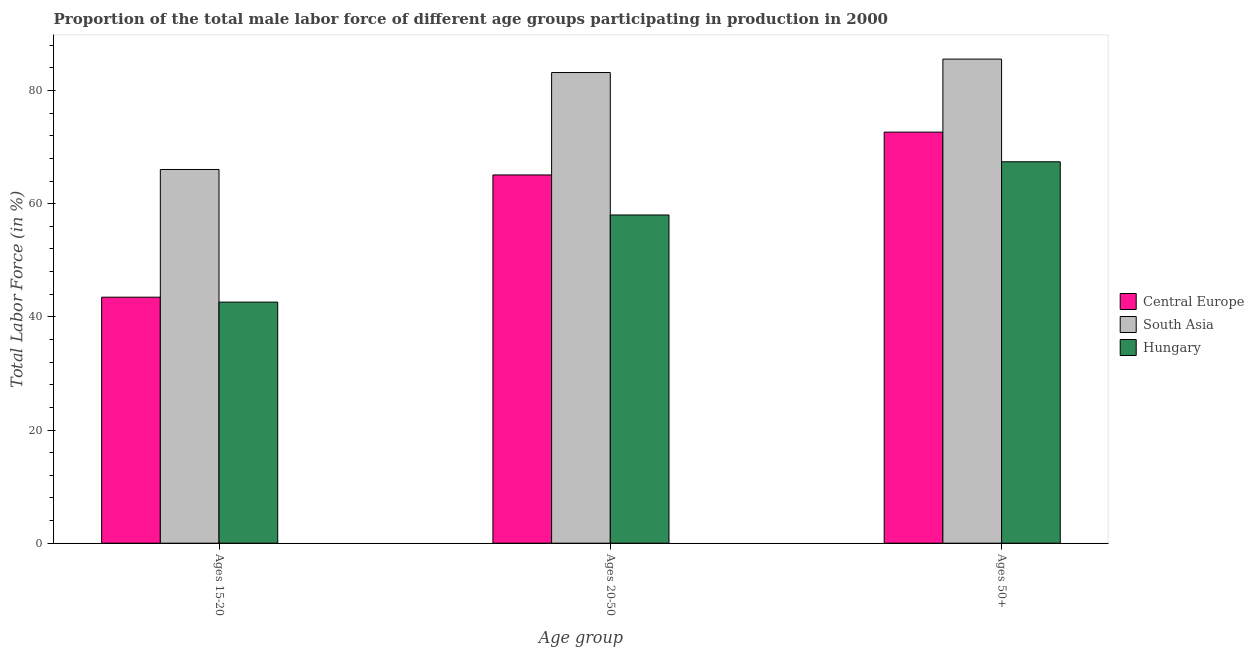How many different coloured bars are there?
Your answer should be compact. 3. How many groups of bars are there?
Provide a succinct answer. 3. Are the number of bars per tick equal to the number of legend labels?
Offer a very short reply. Yes. Are the number of bars on each tick of the X-axis equal?
Offer a very short reply. Yes. How many bars are there on the 1st tick from the left?
Provide a short and direct response. 3. How many bars are there on the 1st tick from the right?
Your answer should be very brief. 3. What is the label of the 1st group of bars from the left?
Offer a terse response. Ages 15-20. What is the percentage of male labor force above age 50 in Central Europe?
Ensure brevity in your answer.  72.64. Across all countries, what is the maximum percentage of male labor force within the age group 15-20?
Provide a short and direct response. 66.04. Across all countries, what is the minimum percentage of male labor force within the age group 20-50?
Your answer should be compact. 58. In which country was the percentage of male labor force within the age group 20-50 maximum?
Provide a succinct answer. South Asia. In which country was the percentage of male labor force above age 50 minimum?
Provide a short and direct response. Hungary. What is the total percentage of male labor force above age 50 in the graph?
Keep it short and to the point. 225.59. What is the difference between the percentage of male labor force above age 50 in Central Europe and that in Hungary?
Your response must be concise. 5.24. What is the difference between the percentage of male labor force within the age group 20-50 in South Asia and the percentage of male labor force above age 50 in Hungary?
Make the answer very short. 15.77. What is the average percentage of male labor force within the age group 15-20 per country?
Your response must be concise. 50.7. What is the difference between the percentage of male labor force within the age group 20-50 and percentage of male labor force above age 50 in Hungary?
Ensure brevity in your answer.  -9.4. What is the ratio of the percentage of male labor force within the age group 15-20 in Central Europe to that in South Asia?
Your answer should be very brief. 0.66. Is the percentage of male labor force within the age group 20-50 in Hungary less than that in South Asia?
Your answer should be compact. Yes. What is the difference between the highest and the second highest percentage of male labor force within the age group 20-50?
Your answer should be very brief. 18.1. What is the difference between the highest and the lowest percentage of male labor force within the age group 20-50?
Provide a succinct answer. 25.17. In how many countries, is the percentage of male labor force within the age group 15-20 greater than the average percentage of male labor force within the age group 15-20 taken over all countries?
Your answer should be compact. 1. What does the 1st bar from the left in Ages 20-50 represents?
Ensure brevity in your answer.  Central Europe. What does the 3rd bar from the right in Ages 20-50 represents?
Your response must be concise. Central Europe. Is it the case that in every country, the sum of the percentage of male labor force within the age group 15-20 and percentage of male labor force within the age group 20-50 is greater than the percentage of male labor force above age 50?
Give a very brief answer. Yes. How many bars are there?
Provide a short and direct response. 9. Does the graph contain any zero values?
Give a very brief answer. No. Does the graph contain grids?
Provide a short and direct response. No. Where does the legend appear in the graph?
Give a very brief answer. Center right. How many legend labels are there?
Make the answer very short. 3. How are the legend labels stacked?
Keep it short and to the point. Vertical. What is the title of the graph?
Your answer should be compact. Proportion of the total male labor force of different age groups participating in production in 2000. Does "Suriname" appear as one of the legend labels in the graph?
Offer a terse response. No. What is the label or title of the X-axis?
Make the answer very short. Age group. What is the Total Labor Force (in %) in Central Europe in Ages 15-20?
Your answer should be compact. 43.47. What is the Total Labor Force (in %) of South Asia in Ages 15-20?
Your answer should be very brief. 66.04. What is the Total Labor Force (in %) in Hungary in Ages 15-20?
Offer a very short reply. 42.6. What is the Total Labor Force (in %) of Central Europe in Ages 20-50?
Give a very brief answer. 65.07. What is the Total Labor Force (in %) of South Asia in Ages 20-50?
Your response must be concise. 83.17. What is the Total Labor Force (in %) of Hungary in Ages 20-50?
Give a very brief answer. 58. What is the Total Labor Force (in %) in Central Europe in Ages 50+?
Make the answer very short. 72.64. What is the Total Labor Force (in %) of South Asia in Ages 50+?
Offer a terse response. 85.55. What is the Total Labor Force (in %) in Hungary in Ages 50+?
Keep it short and to the point. 67.4. Across all Age group, what is the maximum Total Labor Force (in %) of Central Europe?
Give a very brief answer. 72.64. Across all Age group, what is the maximum Total Labor Force (in %) in South Asia?
Provide a short and direct response. 85.55. Across all Age group, what is the maximum Total Labor Force (in %) in Hungary?
Your answer should be very brief. 67.4. Across all Age group, what is the minimum Total Labor Force (in %) in Central Europe?
Provide a short and direct response. 43.47. Across all Age group, what is the minimum Total Labor Force (in %) of South Asia?
Keep it short and to the point. 66.04. Across all Age group, what is the minimum Total Labor Force (in %) in Hungary?
Offer a very short reply. 42.6. What is the total Total Labor Force (in %) of Central Europe in the graph?
Provide a succinct answer. 181.18. What is the total Total Labor Force (in %) of South Asia in the graph?
Your answer should be very brief. 234.76. What is the total Total Labor Force (in %) of Hungary in the graph?
Your answer should be very brief. 168. What is the difference between the Total Labor Force (in %) in Central Europe in Ages 15-20 and that in Ages 20-50?
Your response must be concise. -21.6. What is the difference between the Total Labor Force (in %) in South Asia in Ages 15-20 and that in Ages 20-50?
Ensure brevity in your answer.  -17.13. What is the difference between the Total Labor Force (in %) of Hungary in Ages 15-20 and that in Ages 20-50?
Offer a terse response. -15.4. What is the difference between the Total Labor Force (in %) in Central Europe in Ages 15-20 and that in Ages 50+?
Your answer should be very brief. -29.17. What is the difference between the Total Labor Force (in %) in South Asia in Ages 15-20 and that in Ages 50+?
Give a very brief answer. -19.51. What is the difference between the Total Labor Force (in %) of Hungary in Ages 15-20 and that in Ages 50+?
Offer a very short reply. -24.8. What is the difference between the Total Labor Force (in %) of Central Europe in Ages 20-50 and that in Ages 50+?
Provide a short and direct response. -7.57. What is the difference between the Total Labor Force (in %) in South Asia in Ages 20-50 and that in Ages 50+?
Provide a short and direct response. -2.38. What is the difference between the Total Labor Force (in %) in Central Europe in Ages 15-20 and the Total Labor Force (in %) in South Asia in Ages 20-50?
Make the answer very short. -39.7. What is the difference between the Total Labor Force (in %) of Central Europe in Ages 15-20 and the Total Labor Force (in %) of Hungary in Ages 20-50?
Provide a short and direct response. -14.53. What is the difference between the Total Labor Force (in %) in South Asia in Ages 15-20 and the Total Labor Force (in %) in Hungary in Ages 20-50?
Your answer should be very brief. 8.04. What is the difference between the Total Labor Force (in %) of Central Europe in Ages 15-20 and the Total Labor Force (in %) of South Asia in Ages 50+?
Your response must be concise. -42.08. What is the difference between the Total Labor Force (in %) in Central Europe in Ages 15-20 and the Total Labor Force (in %) in Hungary in Ages 50+?
Keep it short and to the point. -23.93. What is the difference between the Total Labor Force (in %) in South Asia in Ages 15-20 and the Total Labor Force (in %) in Hungary in Ages 50+?
Your answer should be compact. -1.36. What is the difference between the Total Labor Force (in %) of Central Europe in Ages 20-50 and the Total Labor Force (in %) of South Asia in Ages 50+?
Keep it short and to the point. -20.47. What is the difference between the Total Labor Force (in %) in Central Europe in Ages 20-50 and the Total Labor Force (in %) in Hungary in Ages 50+?
Make the answer very short. -2.33. What is the difference between the Total Labor Force (in %) in South Asia in Ages 20-50 and the Total Labor Force (in %) in Hungary in Ages 50+?
Your answer should be compact. 15.77. What is the average Total Labor Force (in %) of Central Europe per Age group?
Make the answer very short. 60.39. What is the average Total Labor Force (in %) of South Asia per Age group?
Ensure brevity in your answer.  78.25. What is the average Total Labor Force (in %) in Hungary per Age group?
Give a very brief answer. 56. What is the difference between the Total Labor Force (in %) in Central Europe and Total Labor Force (in %) in South Asia in Ages 15-20?
Offer a very short reply. -22.57. What is the difference between the Total Labor Force (in %) in Central Europe and Total Labor Force (in %) in Hungary in Ages 15-20?
Offer a terse response. 0.87. What is the difference between the Total Labor Force (in %) of South Asia and Total Labor Force (in %) of Hungary in Ages 15-20?
Make the answer very short. 23.44. What is the difference between the Total Labor Force (in %) in Central Europe and Total Labor Force (in %) in South Asia in Ages 20-50?
Keep it short and to the point. -18.1. What is the difference between the Total Labor Force (in %) in Central Europe and Total Labor Force (in %) in Hungary in Ages 20-50?
Give a very brief answer. 7.07. What is the difference between the Total Labor Force (in %) in South Asia and Total Labor Force (in %) in Hungary in Ages 20-50?
Your response must be concise. 25.17. What is the difference between the Total Labor Force (in %) in Central Europe and Total Labor Force (in %) in South Asia in Ages 50+?
Your response must be concise. -12.91. What is the difference between the Total Labor Force (in %) of Central Europe and Total Labor Force (in %) of Hungary in Ages 50+?
Make the answer very short. 5.24. What is the difference between the Total Labor Force (in %) in South Asia and Total Labor Force (in %) in Hungary in Ages 50+?
Give a very brief answer. 18.15. What is the ratio of the Total Labor Force (in %) in Central Europe in Ages 15-20 to that in Ages 20-50?
Offer a very short reply. 0.67. What is the ratio of the Total Labor Force (in %) of South Asia in Ages 15-20 to that in Ages 20-50?
Give a very brief answer. 0.79. What is the ratio of the Total Labor Force (in %) in Hungary in Ages 15-20 to that in Ages 20-50?
Your response must be concise. 0.73. What is the ratio of the Total Labor Force (in %) of Central Europe in Ages 15-20 to that in Ages 50+?
Provide a short and direct response. 0.6. What is the ratio of the Total Labor Force (in %) of South Asia in Ages 15-20 to that in Ages 50+?
Ensure brevity in your answer.  0.77. What is the ratio of the Total Labor Force (in %) in Hungary in Ages 15-20 to that in Ages 50+?
Keep it short and to the point. 0.63. What is the ratio of the Total Labor Force (in %) of Central Europe in Ages 20-50 to that in Ages 50+?
Your response must be concise. 0.9. What is the ratio of the Total Labor Force (in %) of South Asia in Ages 20-50 to that in Ages 50+?
Ensure brevity in your answer.  0.97. What is the ratio of the Total Labor Force (in %) of Hungary in Ages 20-50 to that in Ages 50+?
Offer a very short reply. 0.86. What is the difference between the highest and the second highest Total Labor Force (in %) of Central Europe?
Your response must be concise. 7.57. What is the difference between the highest and the second highest Total Labor Force (in %) in South Asia?
Offer a very short reply. 2.38. What is the difference between the highest and the second highest Total Labor Force (in %) of Hungary?
Your answer should be compact. 9.4. What is the difference between the highest and the lowest Total Labor Force (in %) of Central Europe?
Ensure brevity in your answer.  29.17. What is the difference between the highest and the lowest Total Labor Force (in %) in South Asia?
Your answer should be very brief. 19.51. What is the difference between the highest and the lowest Total Labor Force (in %) of Hungary?
Ensure brevity in your answer.  24.8. 